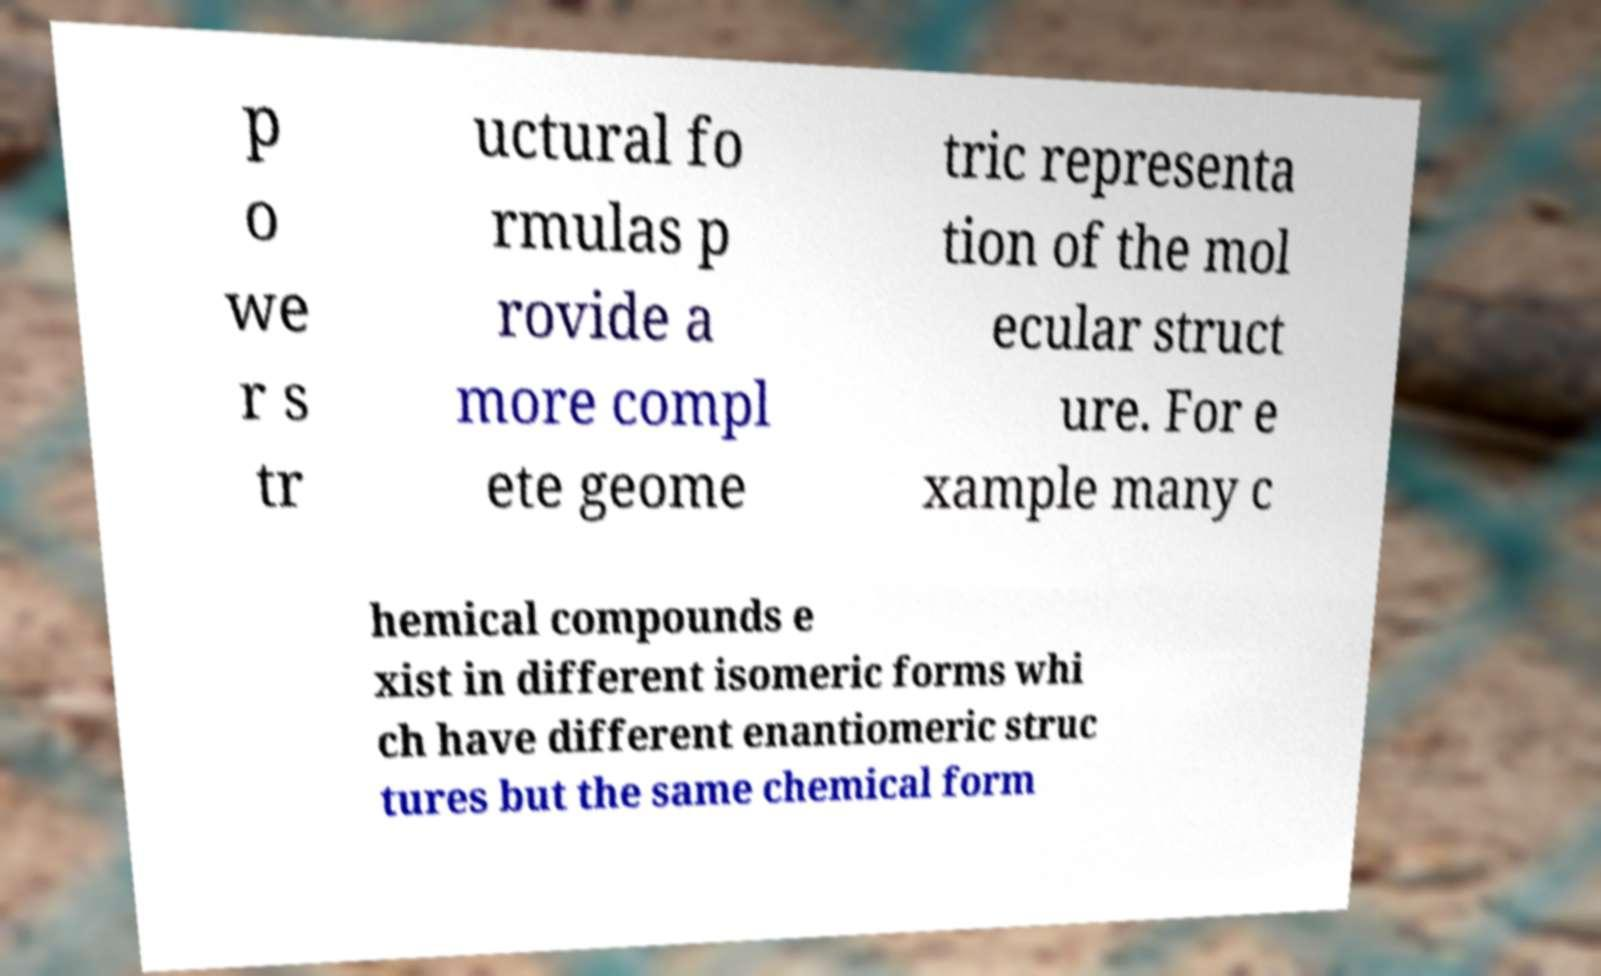Please read and relay the text visible in this image. What does it say? p o we r s tr uctural fo rmulas p rovide a more compl ete geome tric representa tion of the mol ecular struct ure. For e xample many c hemical compounds e xist in different isomeric forms whi ch have different enantiomeric struc tures but the same chemical form 